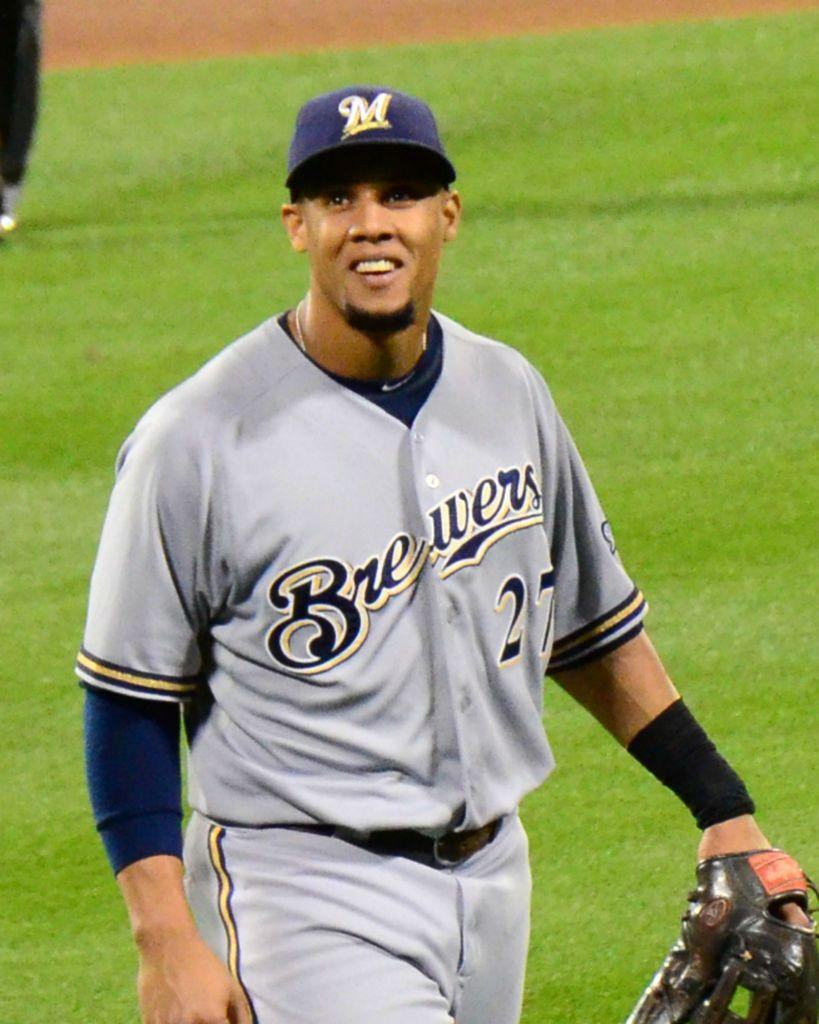<image>
Describe the image concisely. a man on a field what a Brewers shirt 